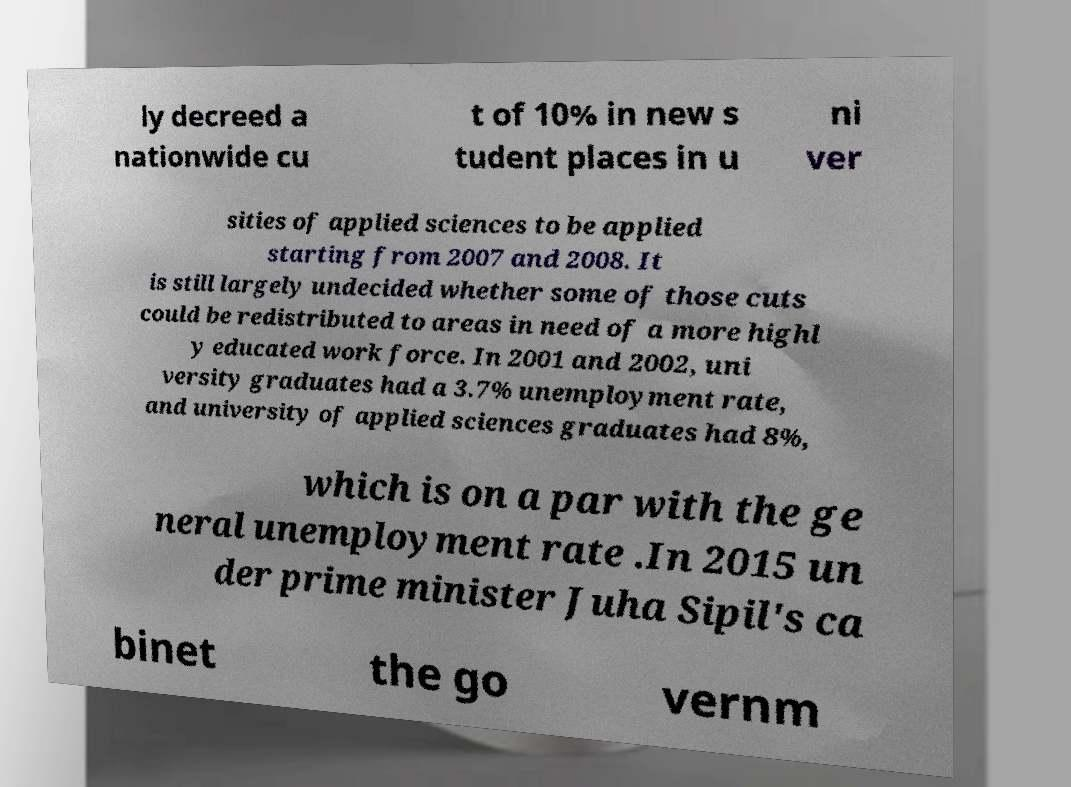Can you read and provide the text displayed in the image?This photo seems to have some interesting text. Can you extract and type it out for me? ly decreed a nationwide cu t of 10% in new s tudent places in u ni ver sities of applied sciences to be applied starting from 2007 and 2008. It is still largely undecided whether some of those cuts could be redistributed to areas in need of a more highl y educated work force. In 2001 and 2002, uni versity graduates had a 3.7% unemployment rate, and university of applied sciences graduates had 8%, which is on a par with the ge neral unemployment rate .In 2015 un der prime minister Juha Sipil's ca binet the go vernm 